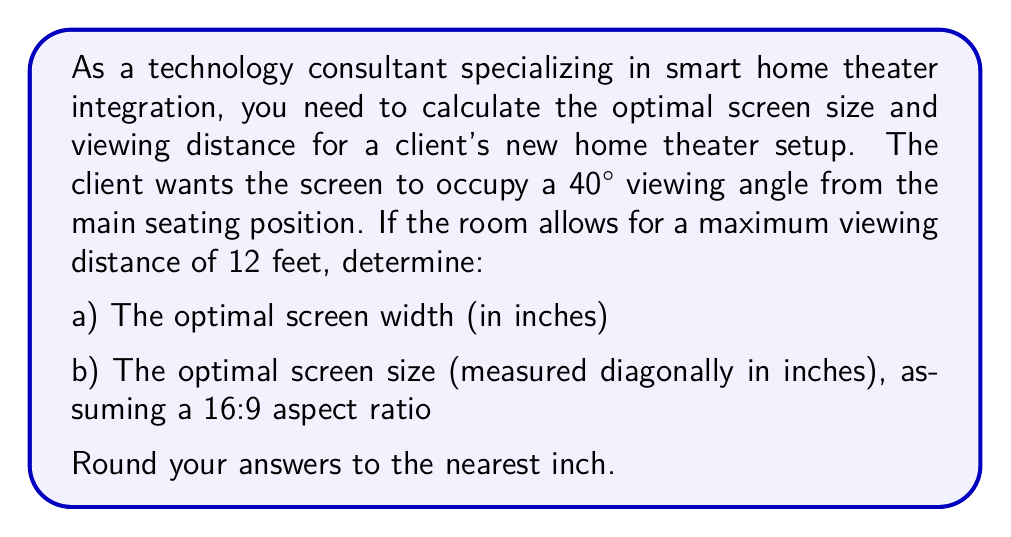Solve this math problem. To solve this problem, we'll use geometric relationships and the properties of right triangles. Let's break it down step-by-step:

1. Calculate the screen width:
   The viewing angle forms an isosceles triangle, with the screen width as the base and the viewing distance as the height. We can use the tangent function to find the relationship between these values.

   $$\tan(\frac{\theta}{2}) = \frac{\text{half screen width}}{\text{viewing distance}}$$

   Where $\theta$ is the viewing angle (40°).

   $$\tan(20°) = \frac{\text{half screen width}}{12 \text{ feet}}$$

   Solving for the screen width:

   $$\text{screen width} = 2 \cdot 12 \text{ feet} \cdot \tan(20°)$$
   $$\text{screen width} = 24 \cdot 0.3640 \text{ feet}$$
   $$\text{screen width} = 8.7360 \text{ feet}$$

   Converting to inches:
   $$\text{screen width} = 8.7360 \cdot 12 = 104.832 \text{ inches}$$

   Rounding to the nearest inch: 105 inches

2. Calculate the screen size (diagonal):
   For a 16:9 aspect ratio, we can use the Pythagorean theorem to find the diagonal size.

   Let $w$ be the width and $h$ be the height of the screen.
   $$h = \frac{9w}{16}$$

   Using the Pythagorean theorem:
   $$d^2 = w^2 + h^2$$
   $$d^2 = w^2 + (\frac{9w}{16})^2$$
   $$d^2 = w^2 + \frac{81w^2}{256}$$
   $$d^2 = \frac{256w^2 + 81w^2}{256}$$
   $$d^2 = \frac{337w^2}{256}$$
   $$d = w \sqrt{\frac{337}{256}} \approx 1.15w$$

   Using our calculated width of 105 inches:
   $$d \approx 1.15 \cdot 105 = 120.75 \text{ inches}$$

   Rounding to the nearest inch: 121 inches
Answer: a) Optimal screen width: 105 inches
b) Optimal screen size (diagonal): 121 inches 